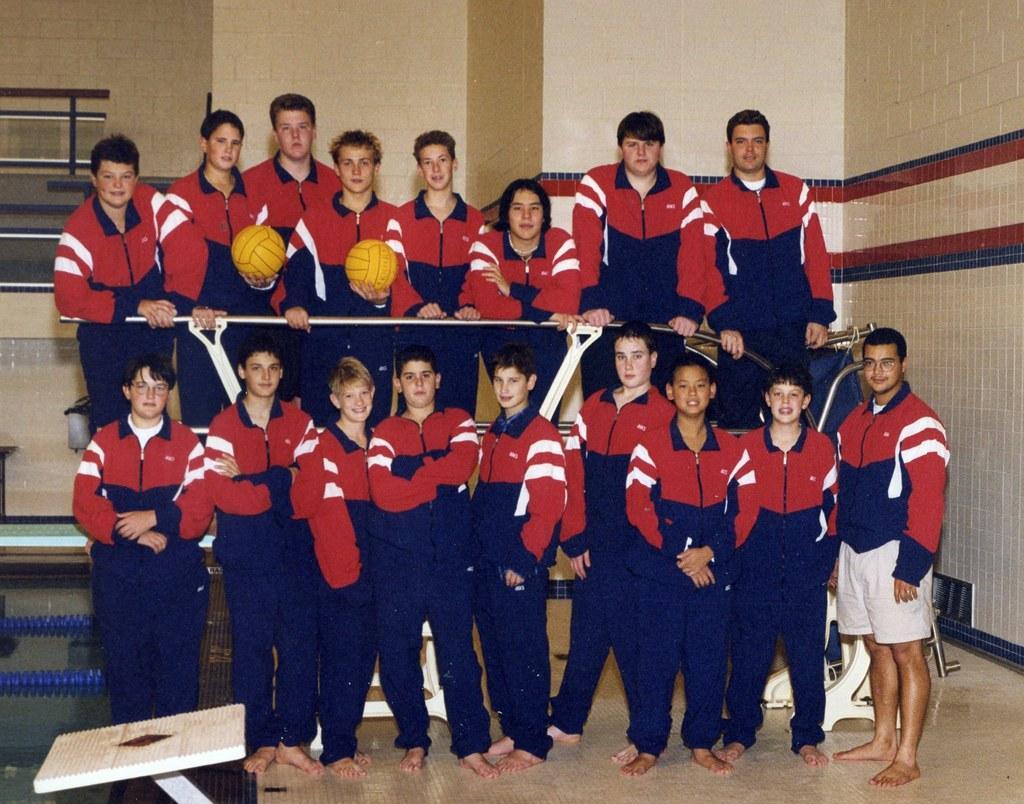In one or two sentences, can you explain what this image depicts? In this image there are group of kids posing for the picture. There are few kids standing on the floor, while the other people are standing behind them. There are two boys who are holding the two balls. In the background there is a wall. On the left side bottom there is a table. 